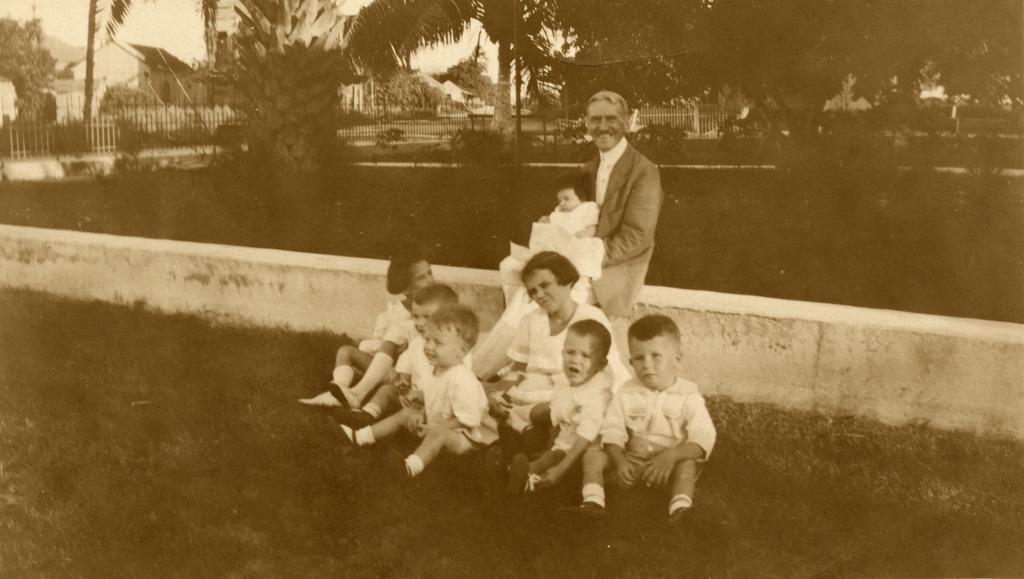Could you give a brief overview of what you see in this image? This is a black and white image. In this image we can see a person placed a girl on his lap is sitting on the wall of a ground, in front of him there are a few more kids sitting on the ground. In the background of the image there are trees, house, railing and sky. 